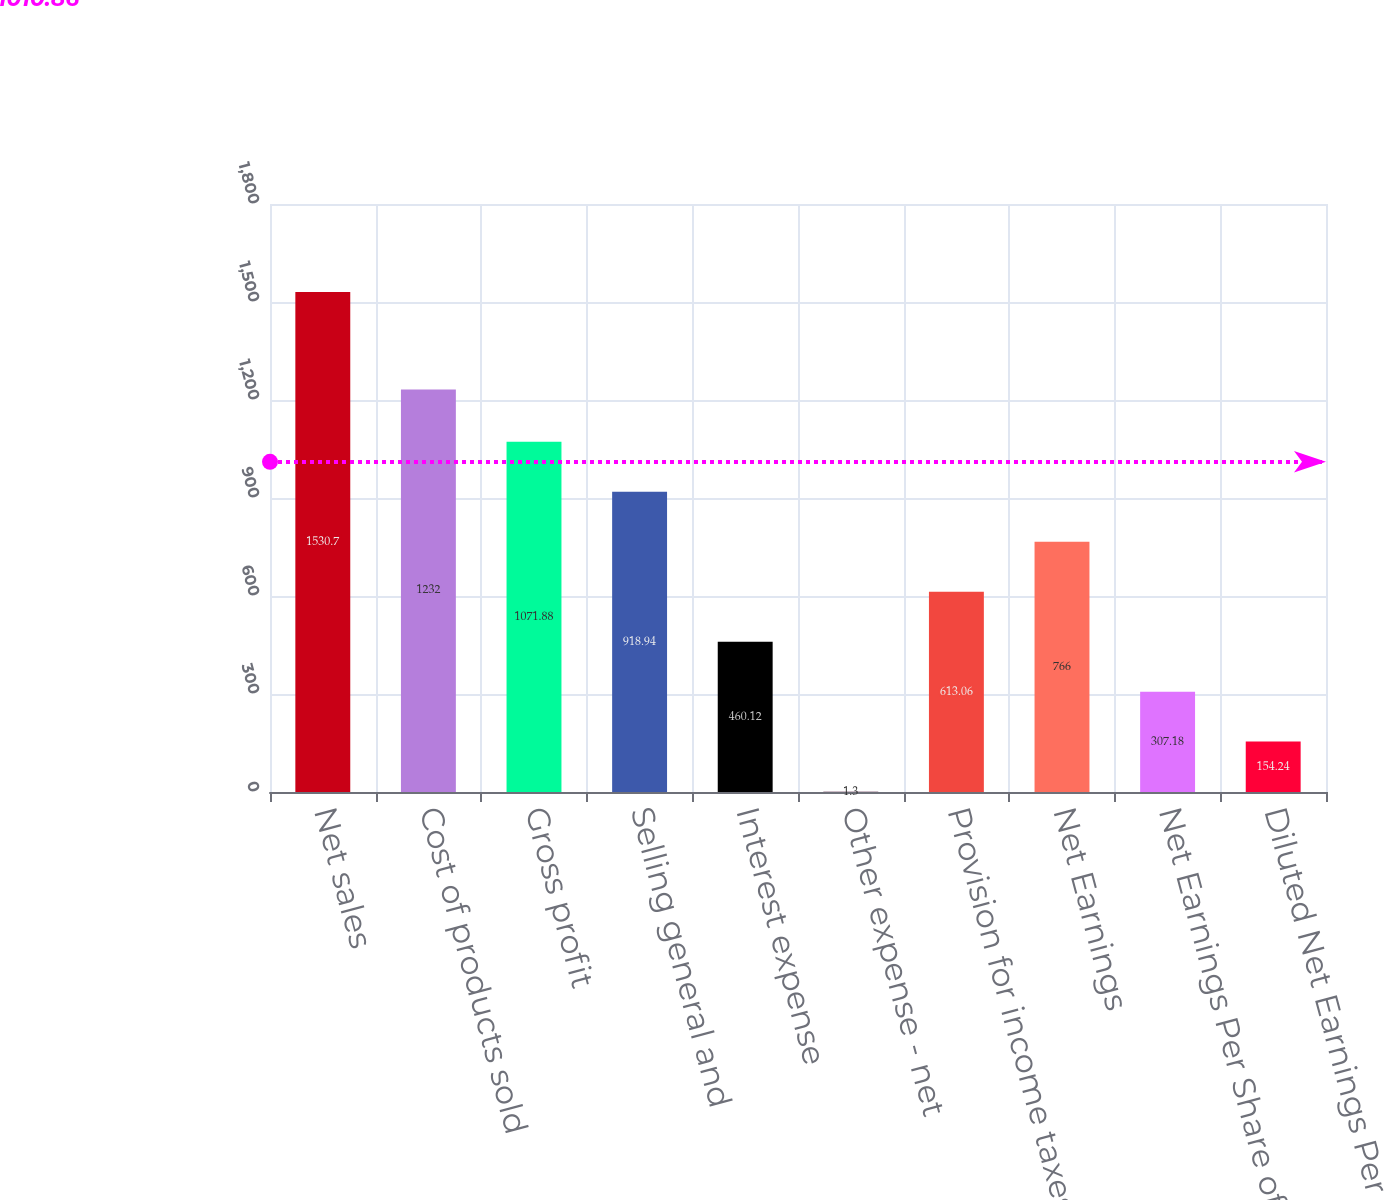Convert chart. <chart><loc_0><loc_0><loc_500><loc_500><bar_chart><fcel>Net sales<fcel>Cost of products sold<fcel>Gross profit<fcel>Selling general and<fcel>Interest expense<fcel>Other expense - net<fcel>Provision for income taxes<fcel>Net Earnings<fcel>Net Earnings Per Share of<fcel>Diluted Net Earnings Per Share<nl><fcel>1530.7<fcel>1232<fcel>1071.88<fcel>918.94<fcel>460.12<fcel>1.3<fcel>613.06<fcel>766<fcel>307.18<fcel>154.24<nl></chart> 